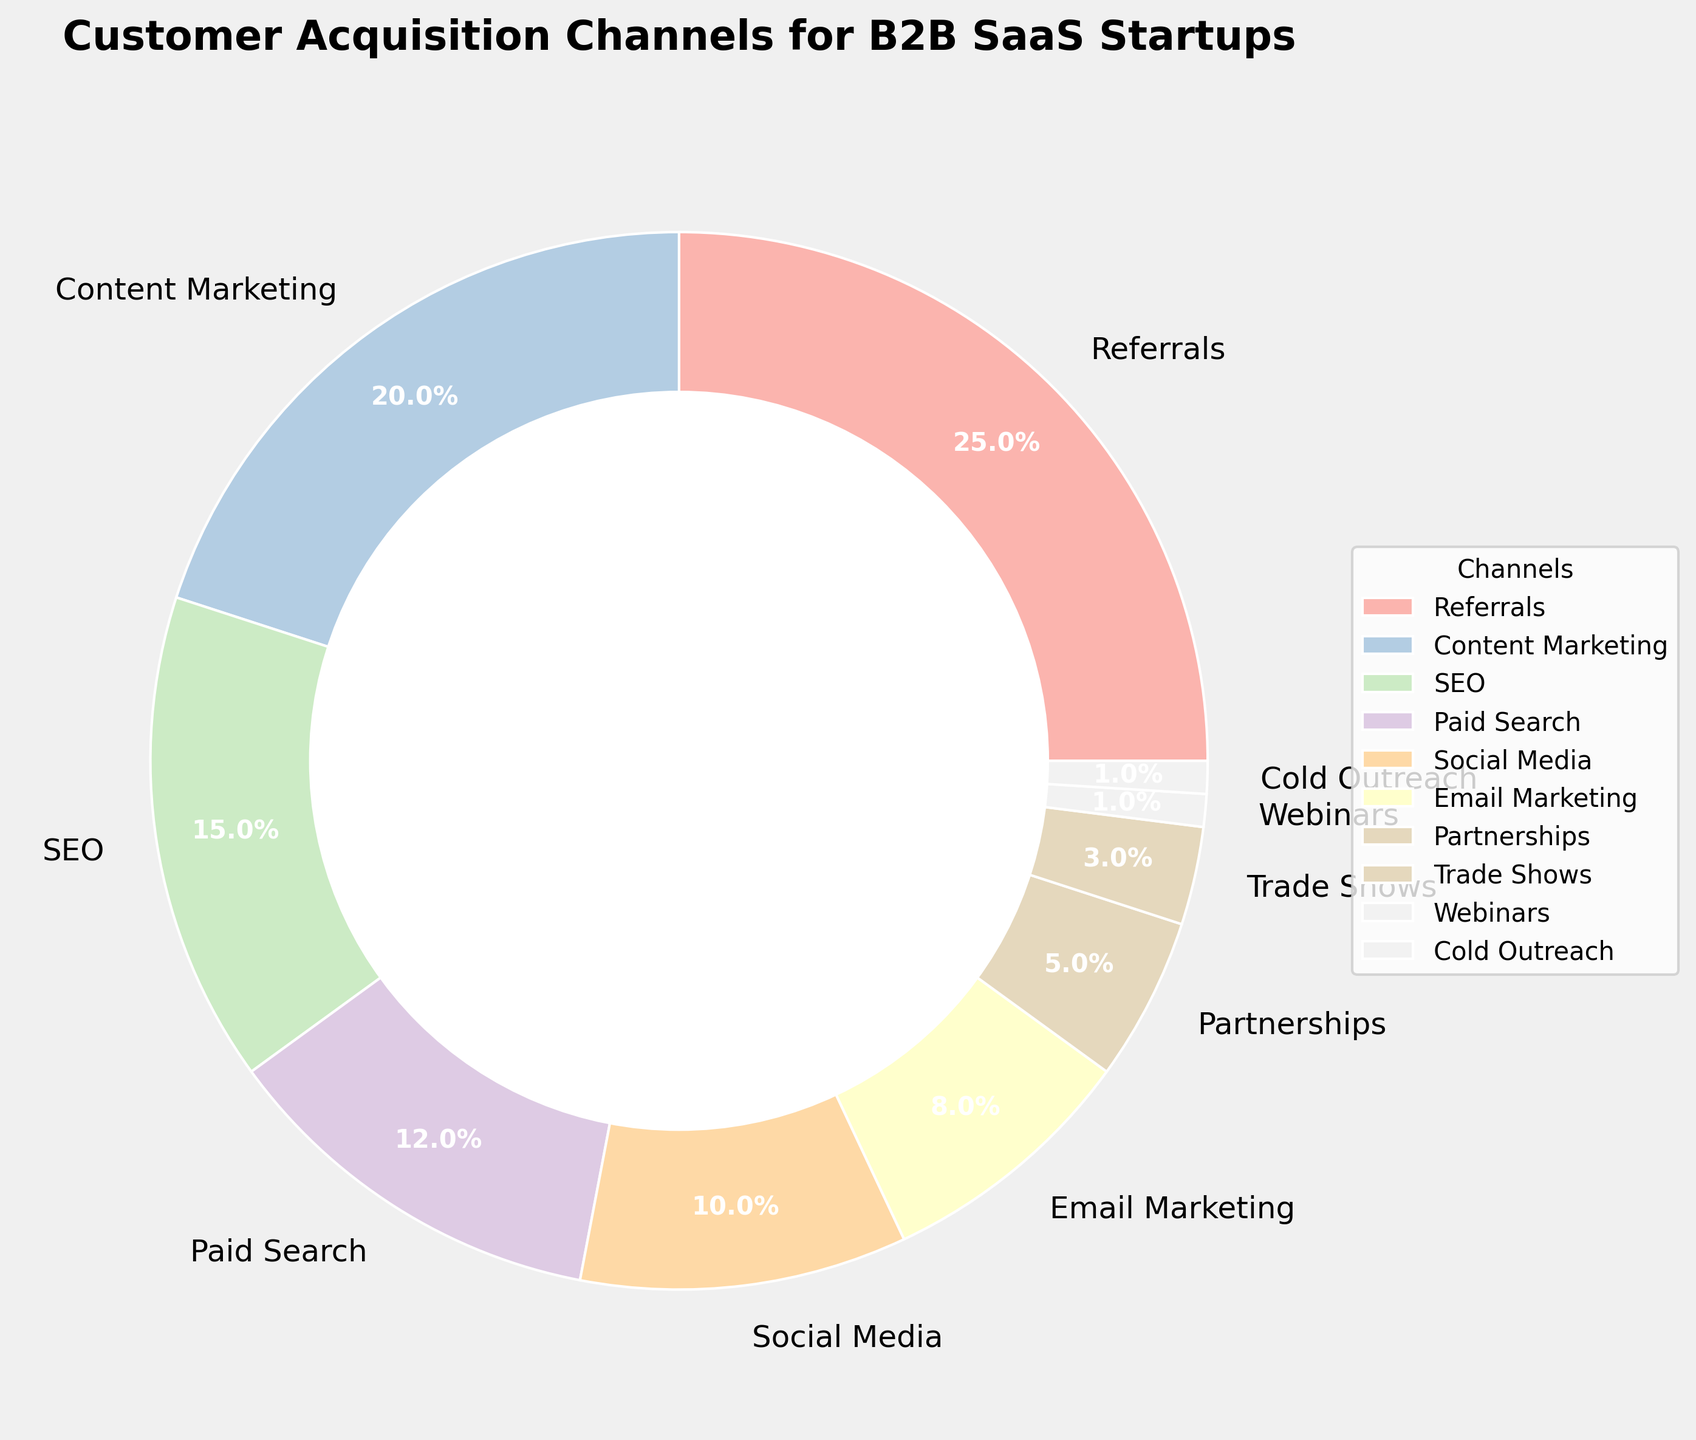What's the most common customer acquisition channel for B2B SaaS startups? Identify the channel with the largest percentage slice in the pie chart, which corresponds to the highest percentage value. In this case, it's 25% for Referrals.
Answer: Referrals Which two channels combined account for the most customer acquisitions? Identify the two largest slices in the pie chart and sum their percentages. Referrals (25%) and Content Marketing (20%) are the two largest, combining to 45%.
Answer: Referrals and Content Marketing How many channels individually account for less than 5% of customer acquisitions? Count the slices in the pie chart that represent less than 5% each. In this case, Partnerships (5%), Trade Shows (3%), Webinars (1%), and Cold Outreach (1%) total four channels.
Answer: 4 How does Paid Search compare to Social Media in terms of customer acquisition percentage? Look at the slices representing Paid Search (12%) and Social Media (10%). Paid Search's slice is larger by 2%.
Answer: Paid Search is 2% higher What percentage of customer acquisitions come from SEO, Paid Search, and Social Media combined? Sum the percentages of the SEO (15%), Paid Search (12%), and Social Media (10%) slices in the pie chart. Their combined percentage is 37%.
Answer: 37% Which channel has the smallest percentage in the pie chart? Identify the smallest slice in the pie chart, which belongs to Webinars and Cold Outreach, each at 1%.
Answer: Webinars and Cold Outreach Of the top three channels, which channel has the second-highest percentage? Rank the top three slices in the pie chart: Referrals (25%), Content Marketing (20%), and SEO (15%). The second-highest percentage belongs to Content Marketing.
Answer: Content Marketing What is the difference in the percentage of acquisitions between Content Marketing and Email Marketing? Subtract the percentage of Email Marketing (8%) from Content Marketing (20%) to find the difference, which is 12%.
Answer: 12% If Referrals and Content Marketing account for 45% of customer acquisitions, what percentage is attributed to all other channels combined? Subtract the combined percentage of Referrals and Content Marketing (45%) from 100%. The remaining percentage is 55%.
Answer: 55% What is the average percentage of customer acquisitions across all channels? Sum the percentages of all channels (100%) and divide by the number of channels (10). The average is 10%.
Answer: 10% 